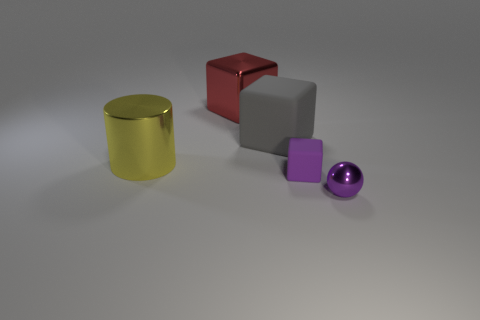There is a tiny rubber thing; does it have the same shape as the large metallic object behind the gray matte object? While the small rubber object and the large metallic object share a cylindrical shape, they differ in scaling, texture, and material properties. The rubber object is significantly smaller, suggesting it could be a scaled-down model or a miniature representation of the larger object. 